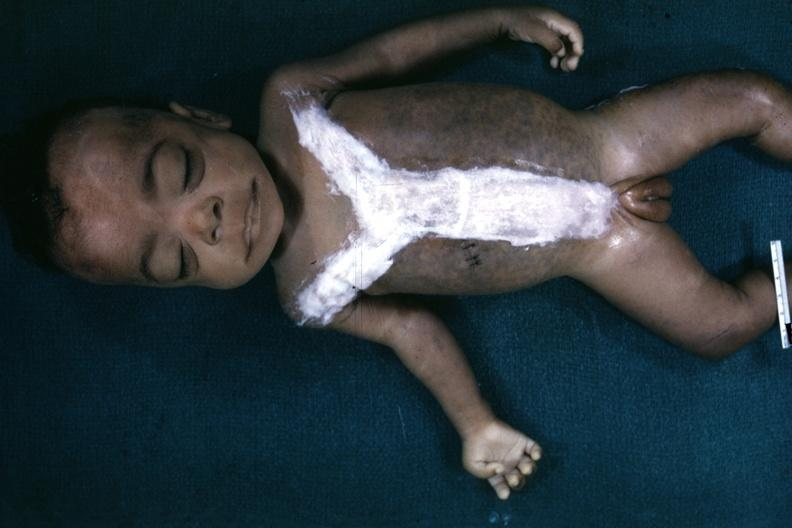s downs syndrome present?
Answer the question using a single word or phrase. Yes 